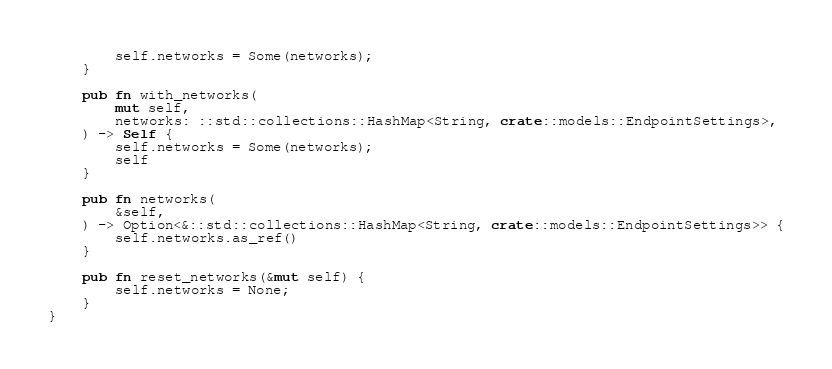<code> <loc_0><loc_0><loc_500><loc_500><_Rust_>        self.networks = Some(networks);
    }

    pub fn with_networks(
        mut self,
        networks: ::std::collections::HashMap<String, crate::models::EndpointSettings>,
    ) -> Self {
        self.networks = Some(networks);
        self
    }

    pub fn networks(
        &self,
    ) -> Option<&::std::collections::HashMap<String, crate::models::EndpointSettings>> {
        self.networks.as_ref()
    }

    pub fn reset_networks(&mut self) {
        self.networks = None;
    }
}
</code> 